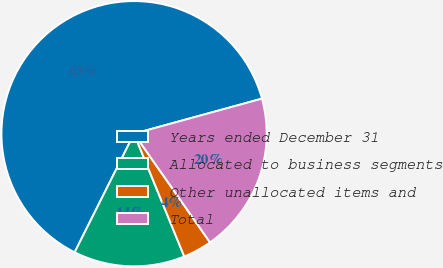<chart> <loc_0><loc_0><loc_500><loc_500><pie_chart><fcel>Years ended December 31<fcel>Allocated to business segments<fcel>Other unallocated items and<fcel>Total<nl><fcel>63.35%<fcel>13.57%<fcel>3.53%<fcel>19.55%<nl></chart> 